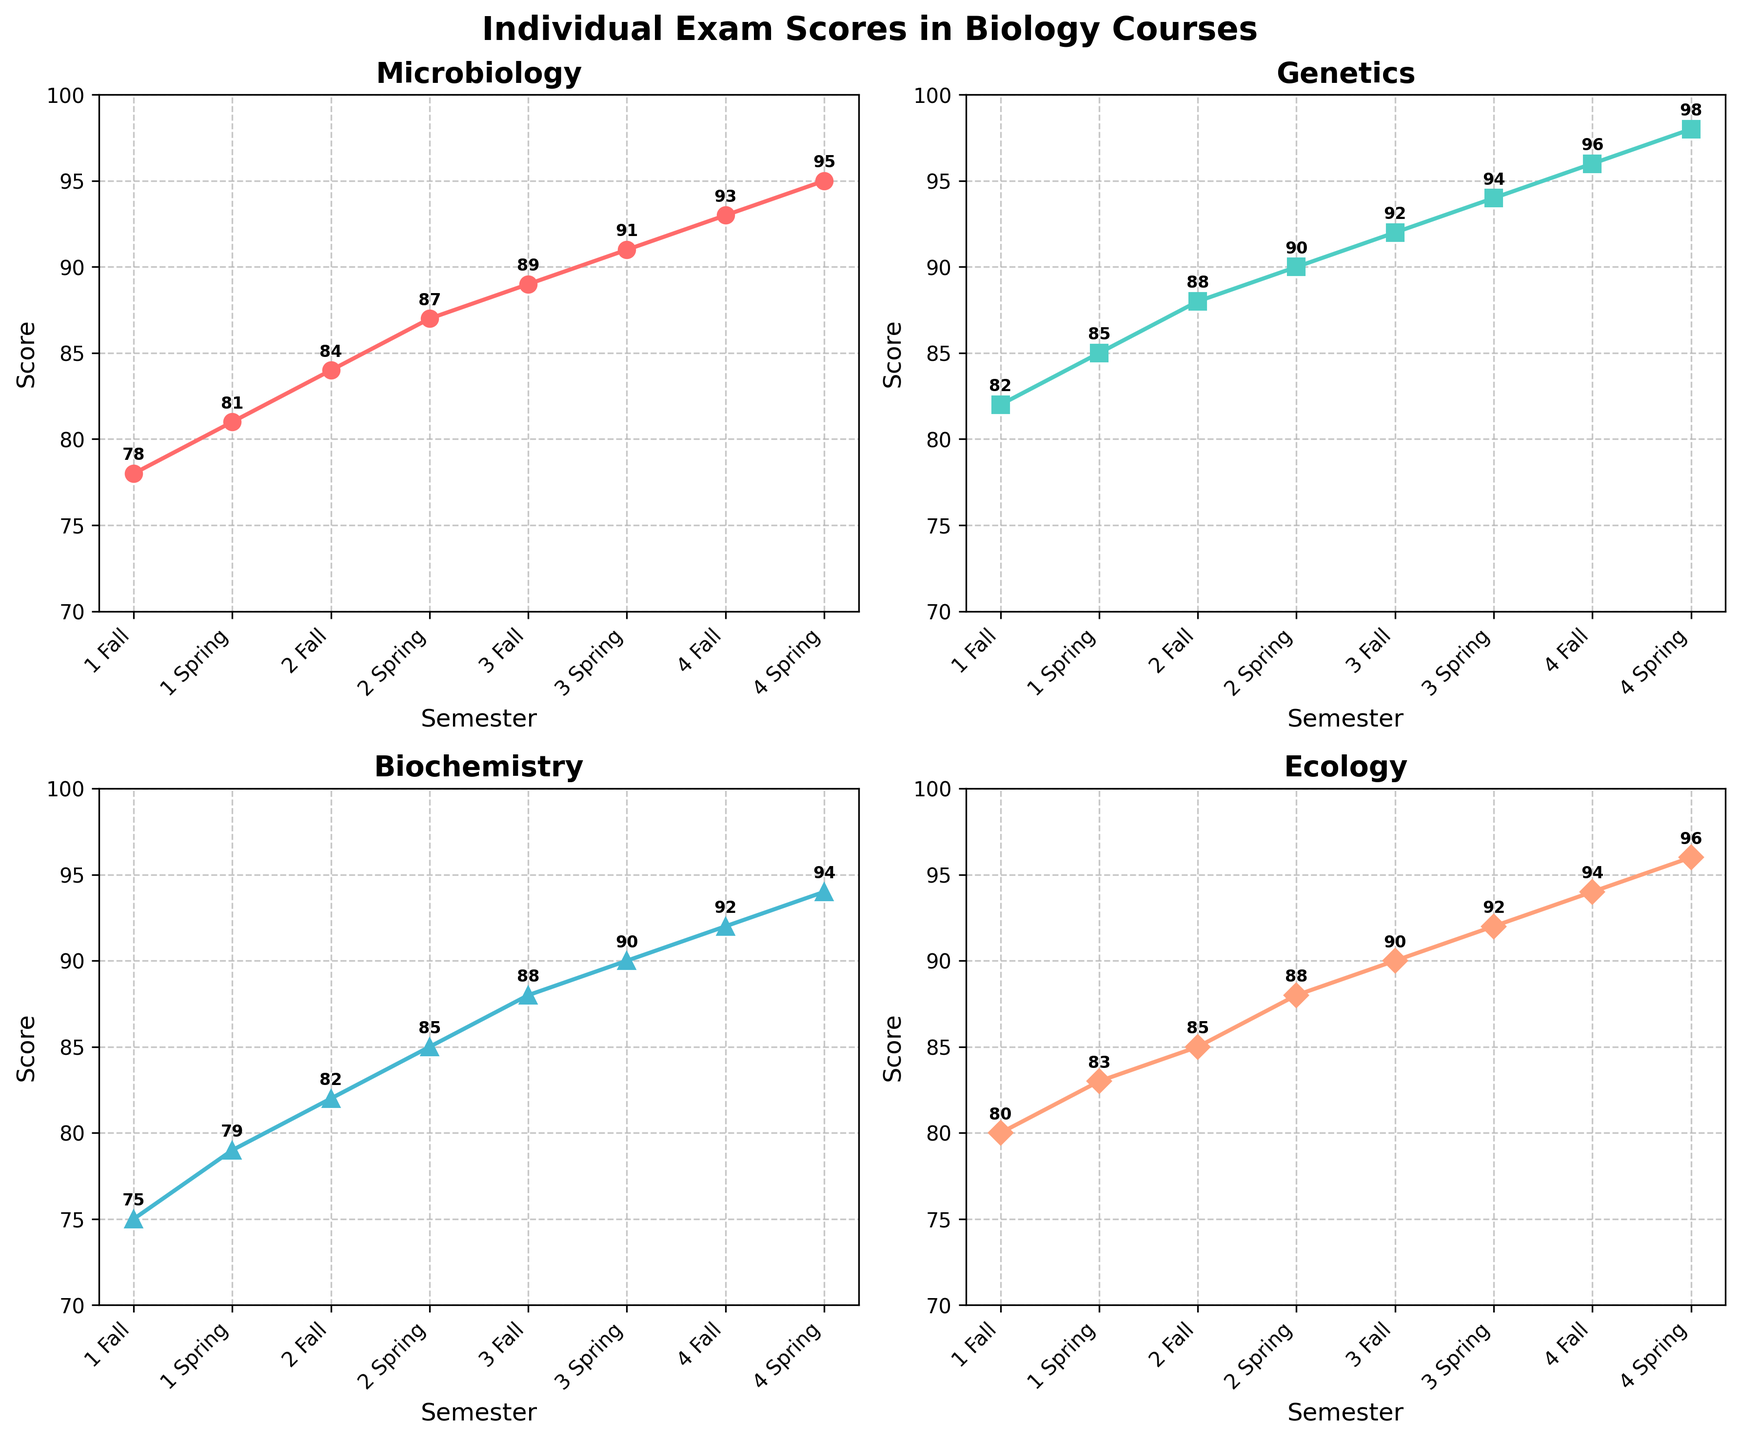What is the title of the overall figure? Look at the top of the figure, where the title is prominently displayed. It's centered and large in size
Answer: Individual Exam Scores in Biology Courses What courses are shown in the subplots? Each subplot is titled with the name of the course. There are four subplots each representing a different course.
Answer: Microbiology, Genetics, Biochemistry, Ecology How does the score in Genetics change from the 1st Fall semester to the 4th Spring semester? Refer to the line chart for Genetics. Identify the first and last data points and observe the trend. The score starts at 82 in 1st Fall and ends at 98 in 4th Spring.
Answer: Increases by 16 points In which semester did Microbiology scores first reach 90? Look at the plot for Microbiology and identify the point where the score first reaches 90.
Answer: 3rd Spring What is the average score for Biochemistry in all semesters? Add all the scores for Biochemistry and divide by the total number of semesters (8). (75 + 79 + 82 + 85 + 88 + 90 + 92 + 94) / 8 = 85.625
Answer: 85.625 Which course has shown the most improvement in scores from the 1st Fall to the 4th Spring? Calculate the difference for each course from the 1st Fall to the 4th Spring and compare them. 
Microbiology (95-78), Genetics (98-82), Biochemistry (94-75), Ecology (96-80). The differences are 17, 16, 19, and 16 respectively.
Answer: Biochemistry In which semester did Ecology scores surpass Biochemistry scores for the first time? Compare the scores in each semester on the plots for Ecology and Biochemistry. Find the semester where Ecology's score is higher than Biochemistry's for the first time. In the 1st Fall, 1st Spring, and 2nd Fall, Ecology scores are 80, 83, and 85, while Biochemistry scores are 75, 79, and 82 respectively. Thus, the first surpassing occurs in the 1st Spring semester.
Answer: 1st Spring How many semesters had a score of 90 or above in Ecology? Count the instances where the Ecology plot shows a score of 90 or above.
Answer: Five semesters Which semester showed the highest score for Microbiology, and what was the score? Identify the highest point on the Microbiology plot and check the corresponding semester and score.
Answer: 4th Spring, 95 Did any course have a decreasing trend in any semester? Observe each course's plot to detect a semester where the score has decreased.
Answer: No 